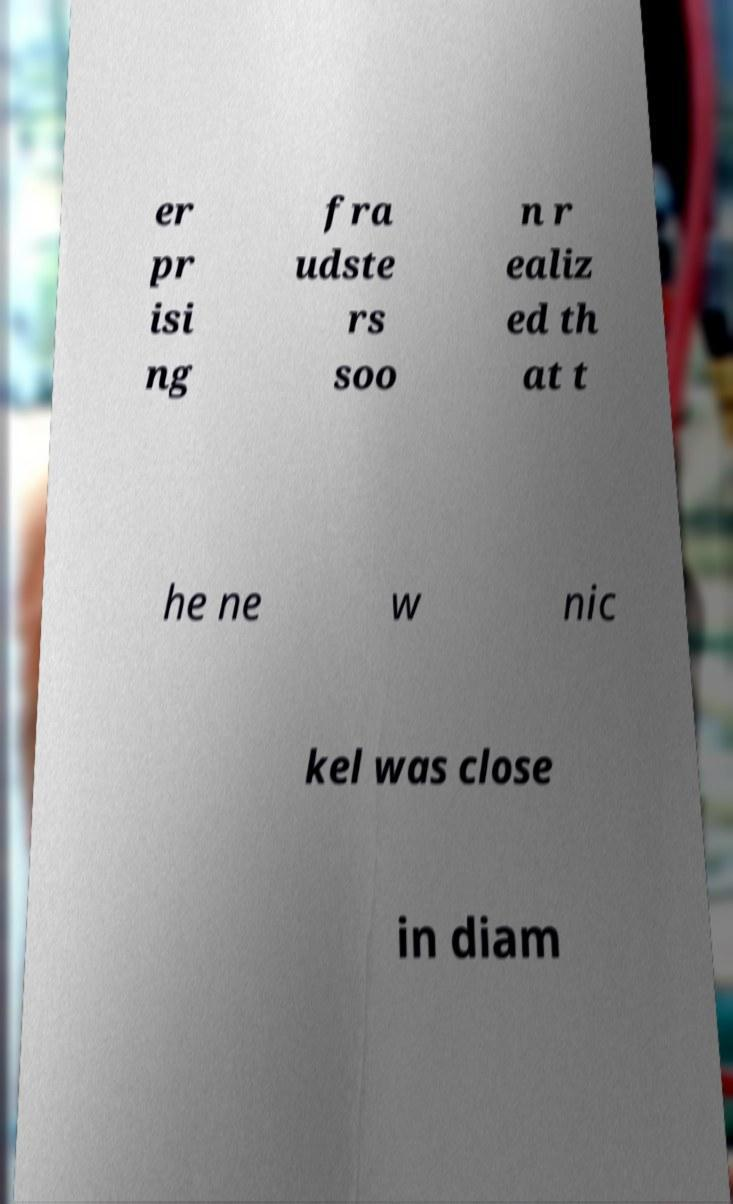For documentation purposes, I need the text within this image transcribed. Could you provide that? er pr isi ng fra udste rs soo n r ealiz ed th at t he ne w nic kel was close in diam 